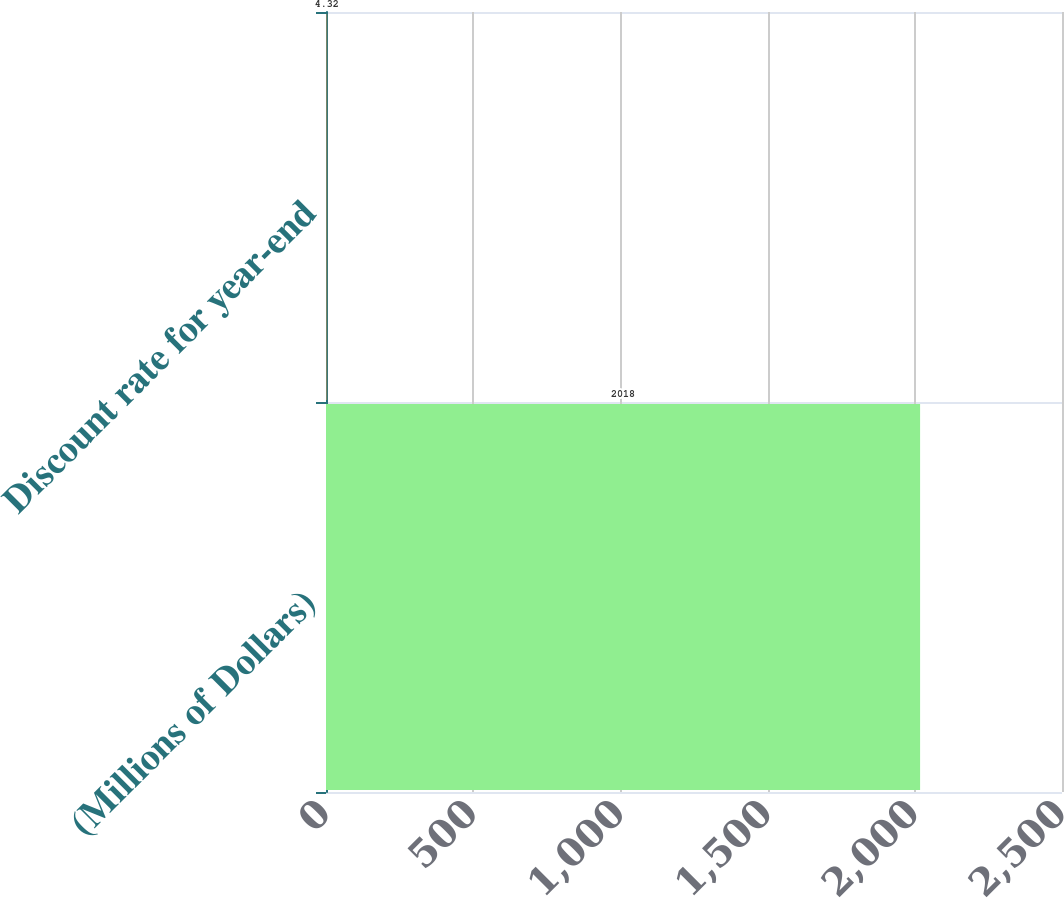Convert chart to OTSL. <chart><loc_0><loc_0><loc_500><loc_500><bar_chart><fcel>(Millions of Dollars)<fcel>Discount rate for year-end<nl><fcel>2018<fcel>4.32<nl></chart> 